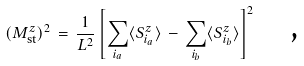Convert formula to latex. <formula><loc_0><loc_0><loc_500><loc_500>( M ^ { z } _ { \text {st} } ) ^ { 2 } \, = \, \frac { 1 } { L ^ { 2 } } \left [ \sum _ { i _ { a } } \langle S _ { i _ { a } } ^ { z } \rangle \, - \, \sum _ { i _ { b } } \langle S _ { i _ { b } } ^ { z } \rangle \right ] ^ { 2 } \quad \text {,}</formula> 